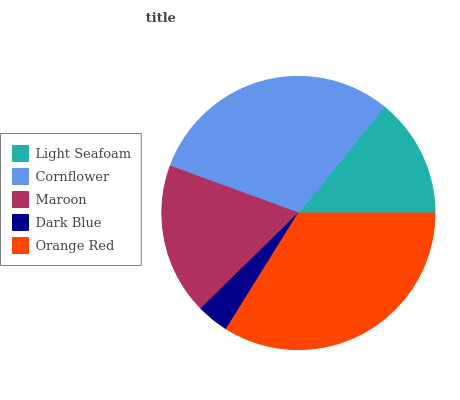Is Dark Blue the minimum?
Answer yes or no. Yes. Is Orange Red the maximum?
Answer yes or no. Yes. Is Cornflower the minimum?
Answer yes or no. No. Is Cornflower the maximum?
Answer yes or no. No. Is Cornflower greater than Light Seafoam?
Answer yes or no. Yes. Is Light Seafoam less than Cornflower?
Answer yes or no. Yes. Is Light Seafoam greater than Cornflower?
Answer yes or no. No. Is Cornflower less than Light Seafoam?
Answer yes or no. No. Is Maroon the high median?
Answer yes or no. Yes. Is Maroon the low median?
Answer yes or no. Yes. Is Light Seafoam the high median?
Answer yes or no. No. Is Orange Red the low median?
Answer yes or no. No. 